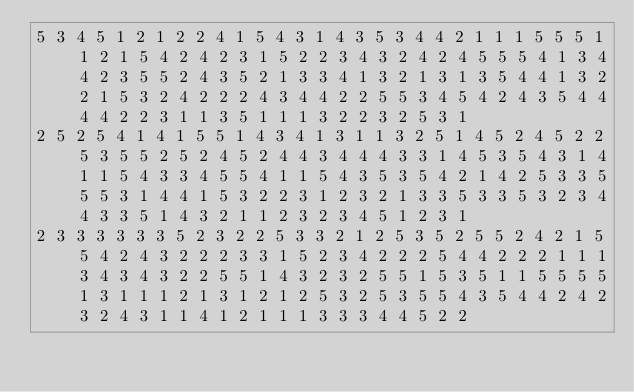Convert code to text. <code><loc_0><loc_0><loc_500><loc_500><_Matlab_>5 3 4 5 1 2 1 2 2 4 1 5 4 3 1 4 3 5 3 4 4 2 1 1 1 5 5 5 1 1 2 1 5 4 2 4 2 3 1 5 2 2 3 4 3 2 4 2 4 5 5 5 4 1 3 4 4 2 3 5 5 2 4 3 5 2 1 3 3 4 1 3 2 1 3 1 3 5 4 4 1 3 2 2 1 5 3 2 4 2 2 2 4 3 4 4 2 2 5 5 3 4 5 4 2 4 3 5 4 4 4 4 2 2 3 1 1 3 5 1 1 1 3 2 2 3 2 5 3 1
2 5 2 5 4 1 4 1 5 5 1 4 3 4 1 3 1 1 3 2 5 1 4 5 2 4 5 2 2 5 3 5 5 2 5 2 4 5 2 4 4 3 4 4 4 3 3 1 4 5 3 5 4 3 1 4 1 1 5 4 3 3 4 5 5 4 1 1 5 4 3 5 3 5 4 2 1 4 2 5 3 3 5 5 5 3 1 4 4 1 5 3 2 2 3 1 2 3 2 1 3 3 5 3 3 5 3 2 3 4 4 3 3 5 1 4 3 2 1 1 2 3 2 3 4 5 1 2 3 1
2 3 3 3 3 3 3 5 2 3 2 2 5 3 3 2 1 2 5 3 5 2 5 5 2 4 2 1 5 5 4 2 4 3 2 2 2 3 3 1 5 2 3 4 2 2 2 5 4 4 2 2 2 1 1 1 3 4 3 4 3 2 2 5 5 1 4 3 2 3 2 5 5 1 5 3 5 1 1 5 5 5 5 1 3 1 1 1 2 1 3 1 2 1 2 5 3 2 5 3 5 5 4 3 5 4 4 2 4 2 3 2 4 3 1 1 4 1 2 1 1 1 3 3 3 4 4 5 2 2</code> 